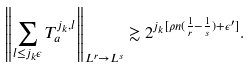<formula> <loc_0><loc_0><loc_500><loc_500>\left \| \sum _ { l \leq j _ { k } \epsilon } T _ { a } ^ { j _ { k } , l } \right \| _ { L ^ { r } \to L ^ { s } } \gtrsim 2 ^ { j _ { k } [ \rho n ( \frac { 1 } { r } - \frac { 1 } { s } ) + \epsilon ^ { \prime } ] } .</formula> 